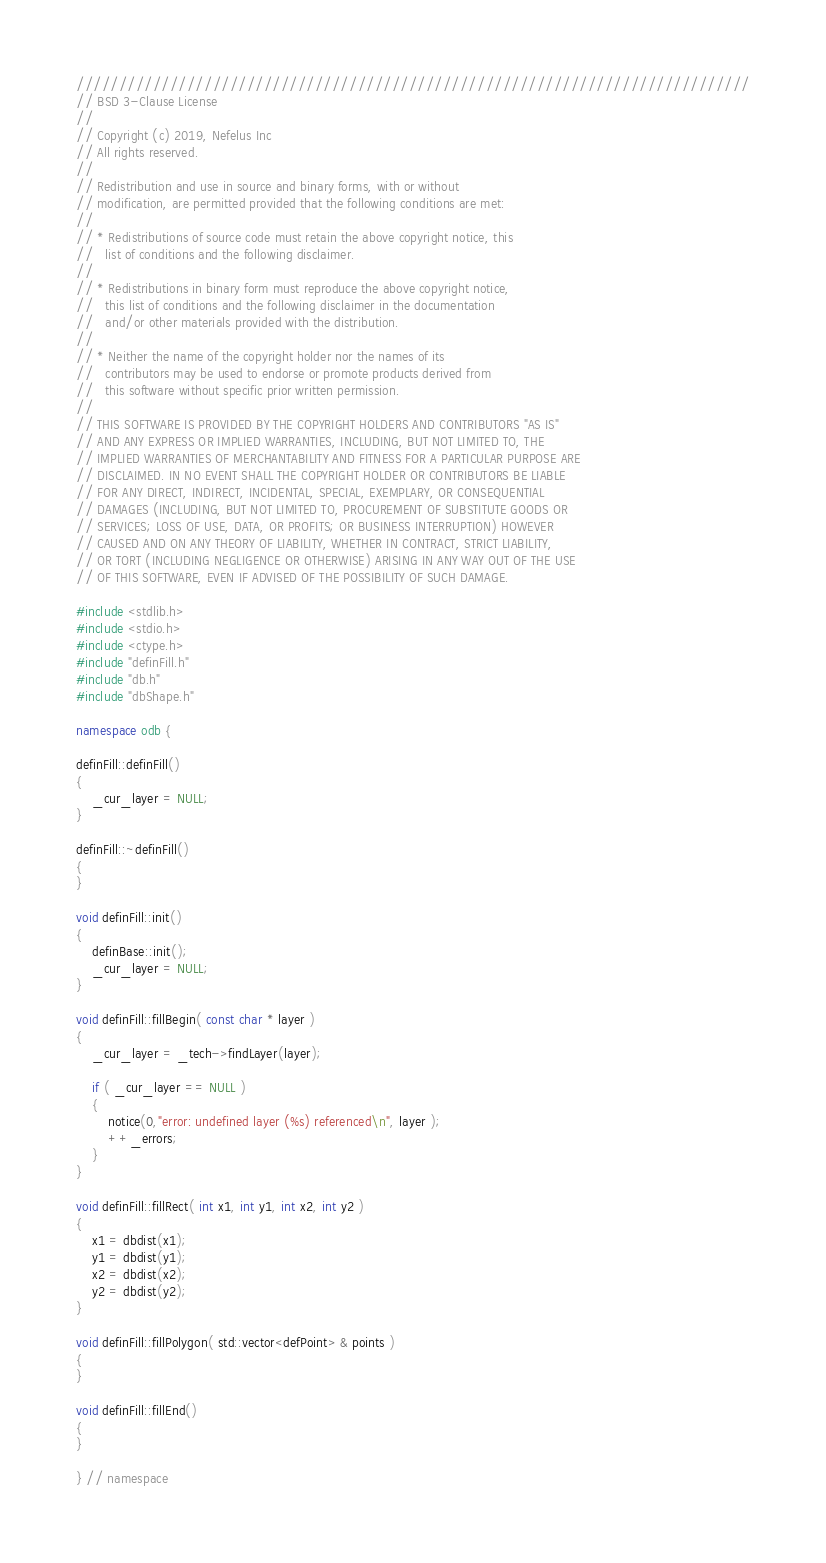Convert code to text. <code><loc_0><loc_0><loc_500><loc_500><_C++_>///////////////////////////////////////////////////////////////////////////////
// BSD 3-Clause License
//
// Copyright (c) 2019, Nefelus Inc
// All rights reserved.
//
// Redistribution and use in source and binary forms, with or without
// modification, are permitted provided that the following conditions are met:
//
// * Redistributions of source code must retain the above copyright notice, this
//   list of conditions and the following disclaimer.
//
// * Redistributions in binary form must reproduce the above copyright notice,
//   this list of conditions and the following disclaimer in the documentation
//   and/or other materials provided with the distribution.
//
// * Neither the name of the copyright holder nor the names of its
//   contributors may be used to endorse or promote products derived from
//   this software without specific prior written permission.
//
// THIS SOFTWARE IS PROVIDED BY THE COPYRIGHT HOLDERS AND CONTRIBUTORS "AS IS"
// AND ANY EXPRESS OR IMPLIED WARRANTIES, INCLUDING, BUT NOT LIMITED TO, THE
// IMPLIED WARRANTIES OF MERCHANTABILITY AND FITNESS FOR A PARTICULAR PURPOSE ARE
// DISCLAIMED. IN NO EVENT SHALL THE COPYRIGHT HOLDER OR CONTRIBUTORS BE LIABLE
// FOR ANY DIRECT, INDIRECT, INCIDENTAL, SPECIAL, EXEMPLARY, OR CONSEQUENTIAL
// DAMAGES (INCLUDING, BUT NOT LIMITED TO, PROCUREMENT OF SUBSTITUTE GOODS OR
// SERVICES; LOSS OF USE, DATA, OR PROFITS; OR BUSINESS INTERRUPTION) HOWEVER
// CAUSED AND ON ANY THEORY OF LIABILITY, WHETHER IN CONTRACT, STRICT LIABILITY,
// OR TORT (INCLUDING NEGLIGENCE OR OTHERWISE) ARISING IN ANY WAY OUT OF THE USE
// OF THIS SOFTWARE, EVEN IF ADVISED OF THE POSSIBILITY OF SUCH DAMAGE.

#include <stdlib.h>
#include <stdio.h>
#include <ctype.h>
#include "definFill.h"
#include "db.h"
#include "dbShape.h"

namespace odb {

definFill::definFill()
{
    _cur_layer = NULL;
}

definFill::~definFill()
{
}

void definFill::init()
{
    definBase::init();
    _cur_layer = NULL;
}

void definFill::fillBegin( const char * layer )
{
    _cur_layer = _tech->findLayer(layer);
    
    if ( _cur_layer == NULL )
    {
        notice(0,"error: undefined layer (%s) referenced\n", layer );
        ++_errors;
    }
}

void definFill::fillRect( int x1, int y1, int x2, int y2 )
{
    x1 = dbdist(x1);
    y1 = dbdist(y1);
    x2 = dbdist(x2);
    y2 = dbdist(y2);
}

void definFill::fillPolygon( std::vector<defPoint> & points )
{
}

void definFill::fillEnd()
{
}

} // namespace
</code> 